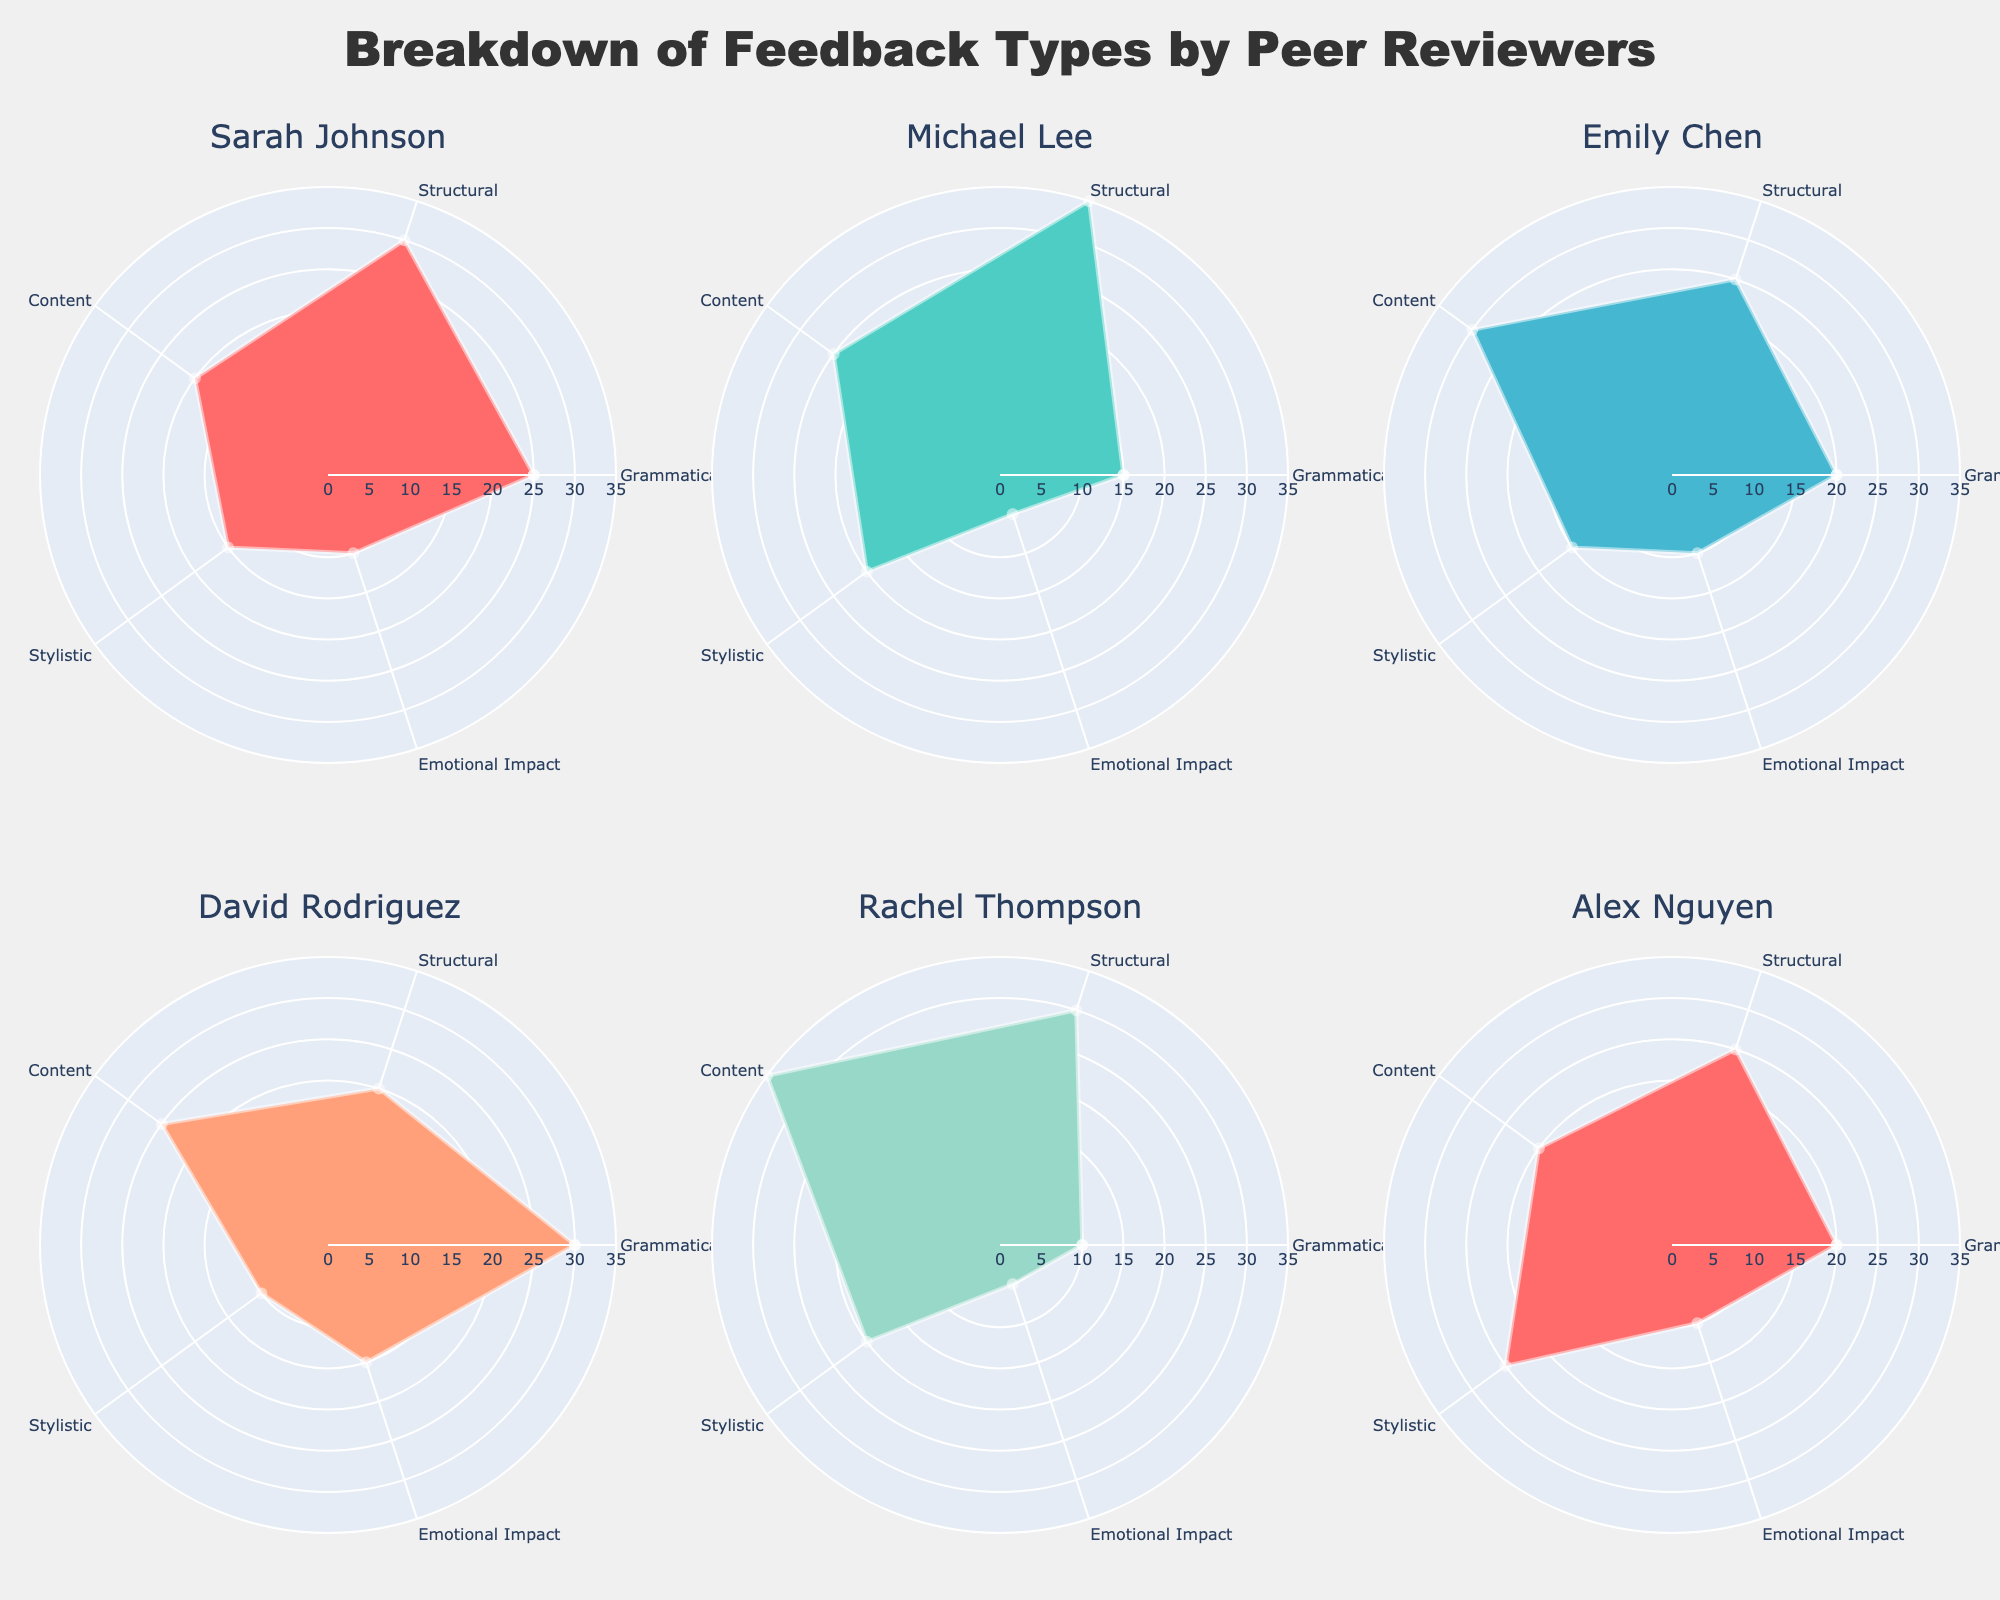Which reviewer gave the highest number of grammatical feedbacks? By looking at the lengths of the Grammatical segment in each subplot, Olivia Parker has the highest number of grammatical feedbacks, as her subplot segment extends the furthest in this category.
Answer: Olivia Parker What is the total amount of stylistic feedback given by Sarah Johnson and Alex Nguyen? To find the total amount, add the Stylistic feedback values for Sarah Johnson (15) and Alex Nguyen (25). 15 + 25 = 40
Answer: 40 Who provided the most emotional impact feedback overall? By comparing the Emotional Impact segments in each subplot, David Rodriguez provided the most emotional impact feedback, which extends the furthest.
Answer: David Rodriguez Which reviewer gave an equal amount of structural and content feedback? By examining the subplots, Michael Lee gave 35 Structural feedback and 25 Content feedback, and these values are not equal. However, no reviewer gave exactly equal amounts for both categories at a first glance, so checking again, Emily Chen gave 25 Structural and 30 Content, which are also unequal. This pattern continues for other reviewers too. Therefore, there is no reviewer with equal Structural and Content feedback.
Answer: None What is the combined amount of content feedback provided by all reviewers shown? Add up the Content feedback values for each reviewer in the subplots shown:
Sarah Johnson (20) + Michael Lee (25) + Emily Chen (30) + David Rodriguez (25) + Rachel Thompson (35) + Alex Nguyen (20).
20 + 25 + 30 + 25 + 35 + 20 = 155
Answer: 155 Who provided the least amount of stylistic feedback? By comparing the Stylistic segments in each subplot, David Rodriguez provided the least amount (10).
Answer: David Rodriguez How many reviewers provided more grammatical feedback than emotional impact feedback? Count the number of subplots where the Grammatical segment is longer than the Emotional Impact segment: Sarah Johnson, Michael Lee, Emily Chen, David Rodriguez, Olivia Parker, and Alex Nguyen. That's 6 out of the 6 displayed reviewers.
Answer: 6 Which reviewer has the most balanced feedback (least variation between different feedback types)? By examining the lengths of each feedback type segment in the subplots, Alex Nguyen has the most balanced feedback, with all segments appearing relatively equal.
Answer: Alex Nguyen What is the average grammatical feedback given by all shown reviewers? Add the Grammatical feedback values and divide by the number of shown reviewers: 
(25 + 15 + 20 + 30 + 10 + 20)/6 = 120/6 = 20.
Answer: 20 